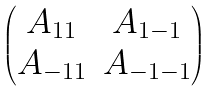<formula> <loc_0><loc_0><loc_500><loc_500>\begin{pmatrix} A _ { 1 1 } & A _ { 1 - 1 } \\ A _ { - 1 1 } & A _ { - 1 - 1 } \end{pmatrix}</formula> 